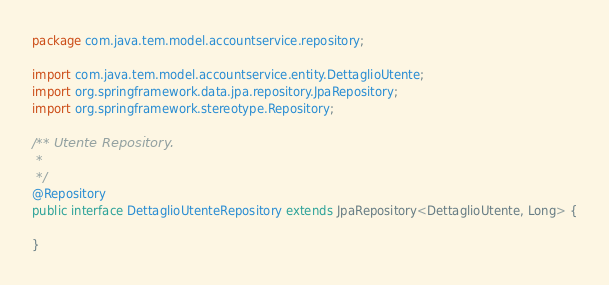Convert code to text. <code><loc_0><loc_0><loc_500><loc_500><_Java_>package com.java.tem.model.accountservice.repository;

import com.java.tem.model.accountservice.entity.DettaglioUtente;
import org.springframework.data.jpa.repository.JpaRepository;
import org.springframework.stereotype.Repository;

/** Utente Repository.
 *
 */
@Repository
public interface DettaglioUtenteRepository extends JpaRepository<DettaglioUtente, Long> {

}
</code> 